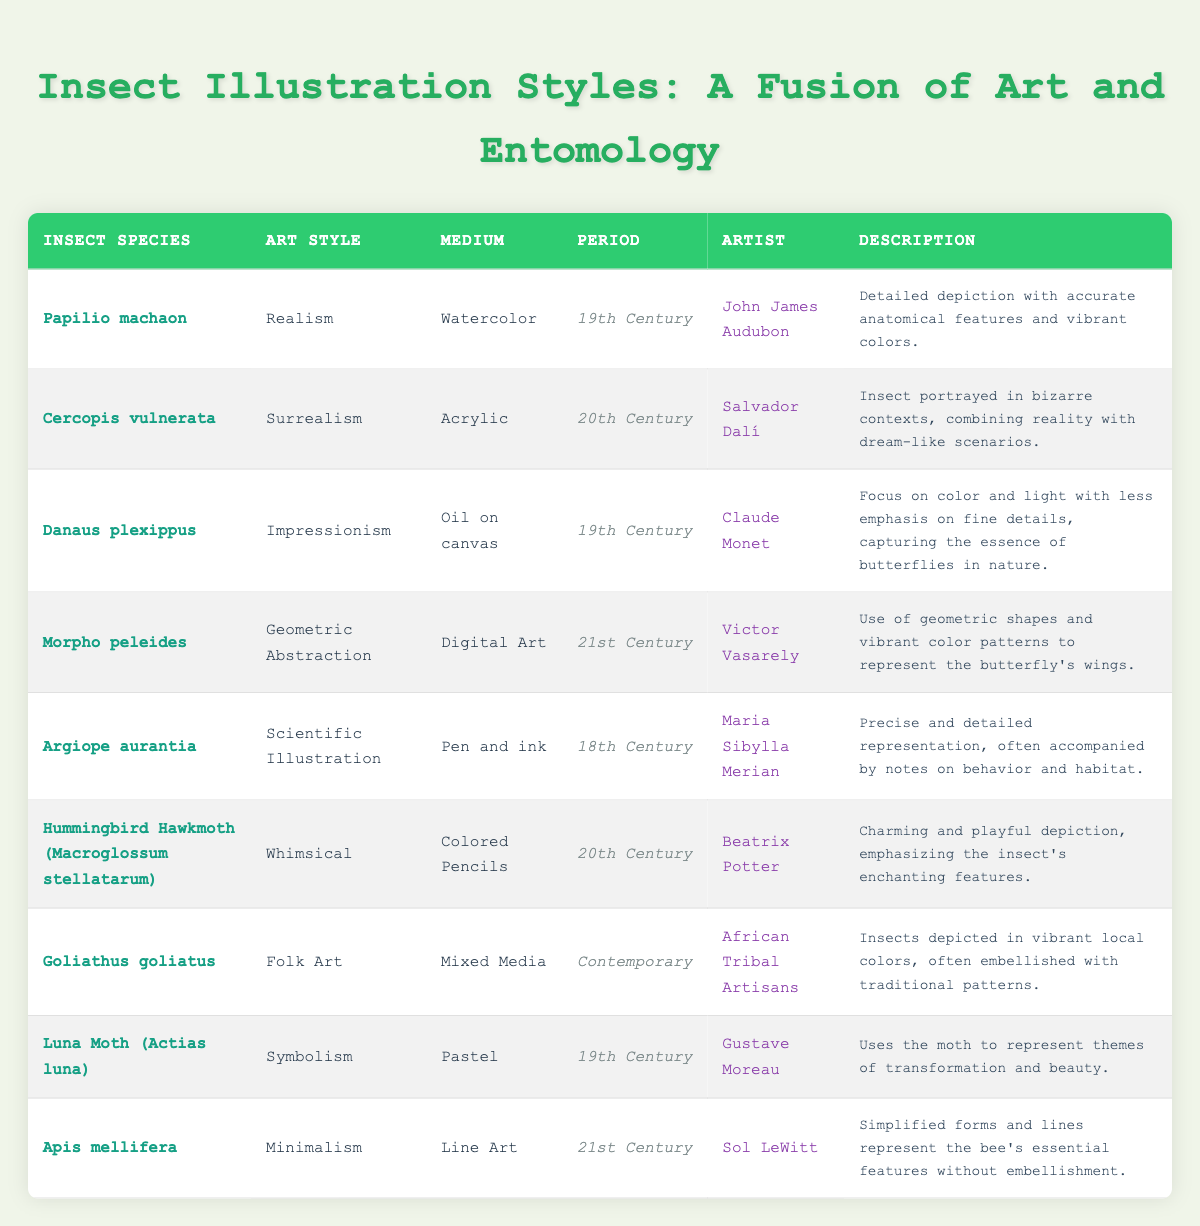What is the medium used for the illustration of Papilio machaon? The medium for the illustration of Papilio machaon is Watercolor, as stated in the table.
Answer: Watercolor Which artist created the illustration for Luna Moth (Actias luna)? The artist for Luna Moth (Actias luna) is Gustave Moreau, as indicated in the table.
Answer: Gustave Moreau How many illustrations represent insect species from the 19th Century? There are four insect illustrations from the 19th Century: Papilio machaon, Danaus plexippus, Luna Moth (Actias luna), and Argiope aurantia, totaling to four entries.
Answer: 4 Is there an illustration of an insect using the medium of Digital Art? Yes, the illustration for Morpho peleides uses Digital Art, as shown in the table.
Answer: Yes Which art style used to illustrate Danaus plexippus focuses on color and light? The art style for Danaus plexippus that focuses on color and light is Impressionism, according to the table.
Answer: Impressionism What is the primary art style used for the illustration of Goliathus goliatus? The primary art style for Goliathus goliatus is Folk Art, as mentioned in the table.
Answer: Folk Art Count the number of illustrations depicting insects with a medium from the 21st Century. There are two illustrations with mediums from the 21st Century: Morpho peleides (Digital Art) and Apis mellifera (Line Art), totaling to two entries.
Answer: 2 Are there more illustrations from the 20th Century than the 18th Century? Yes, there are three illustrations from the 20th Century (Cercopis vulnerata, Hummingbird Hawkmoth, and Danaus plexippus) and one from the 18th Century, indicating more in the 20th Century.
Answer: Yes What is the descriptive focus of the illustration for Apis mellifera? The illustration for Apis mellifera emphasizes simplified forms and lines that represent the bee's essential features without embellishment.
Answer: Simplified forms and lines representation 